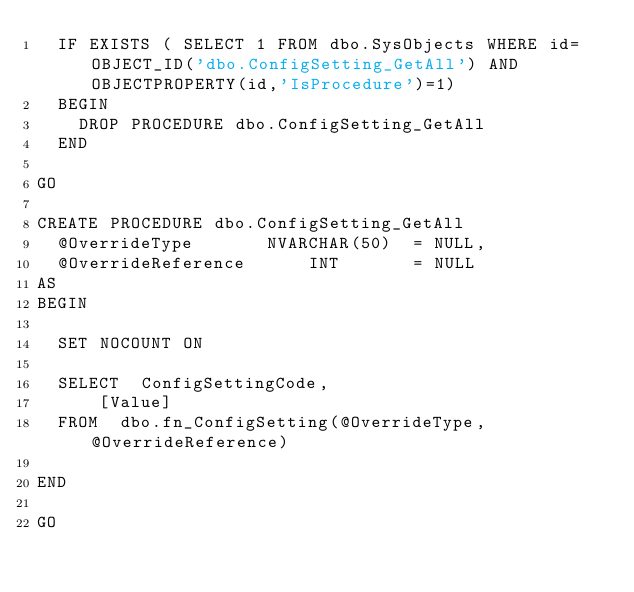<code> <loc_0><loc_0><loc_500><loc_500><_SQL_>  IF EXISTS ( SELECT 1 FROM dbo.SysObjects WHERE id=OBJECT_ID('dbo.ConfigSetting_GetAll') AND OBJECTPROPERTY(id,'IsProcedure')=1)
	BEGIN
		DROP PROCEDURE dbo.ConfigSetting_GetAll
	END

GO

CREATE PROCEDURE dbo.ConfigSetting_GetAll
	@OverrideType				NVARCHAR(50)	= NULL,
	@OverrideReference			INT				= NULL
AS
BEGIN

	SET NOCOUNT ON

	SELECT	ConfigSettingCode, 
			[Value]
	FROM	dbo.fn_ConfigSetting(@OverrideType, @OverrideReference)
	
END

GO</code> 